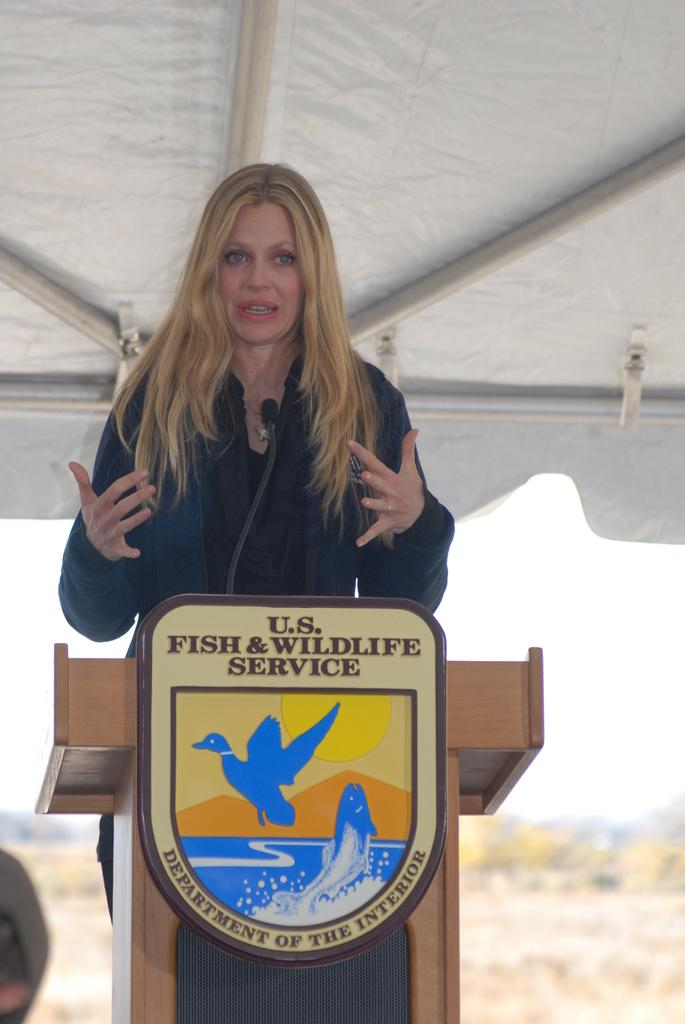<image>
Share a concise interpretation of the image provided. A woman stands in front of a U.S Fish and Wildlife Service logo on a podium. 